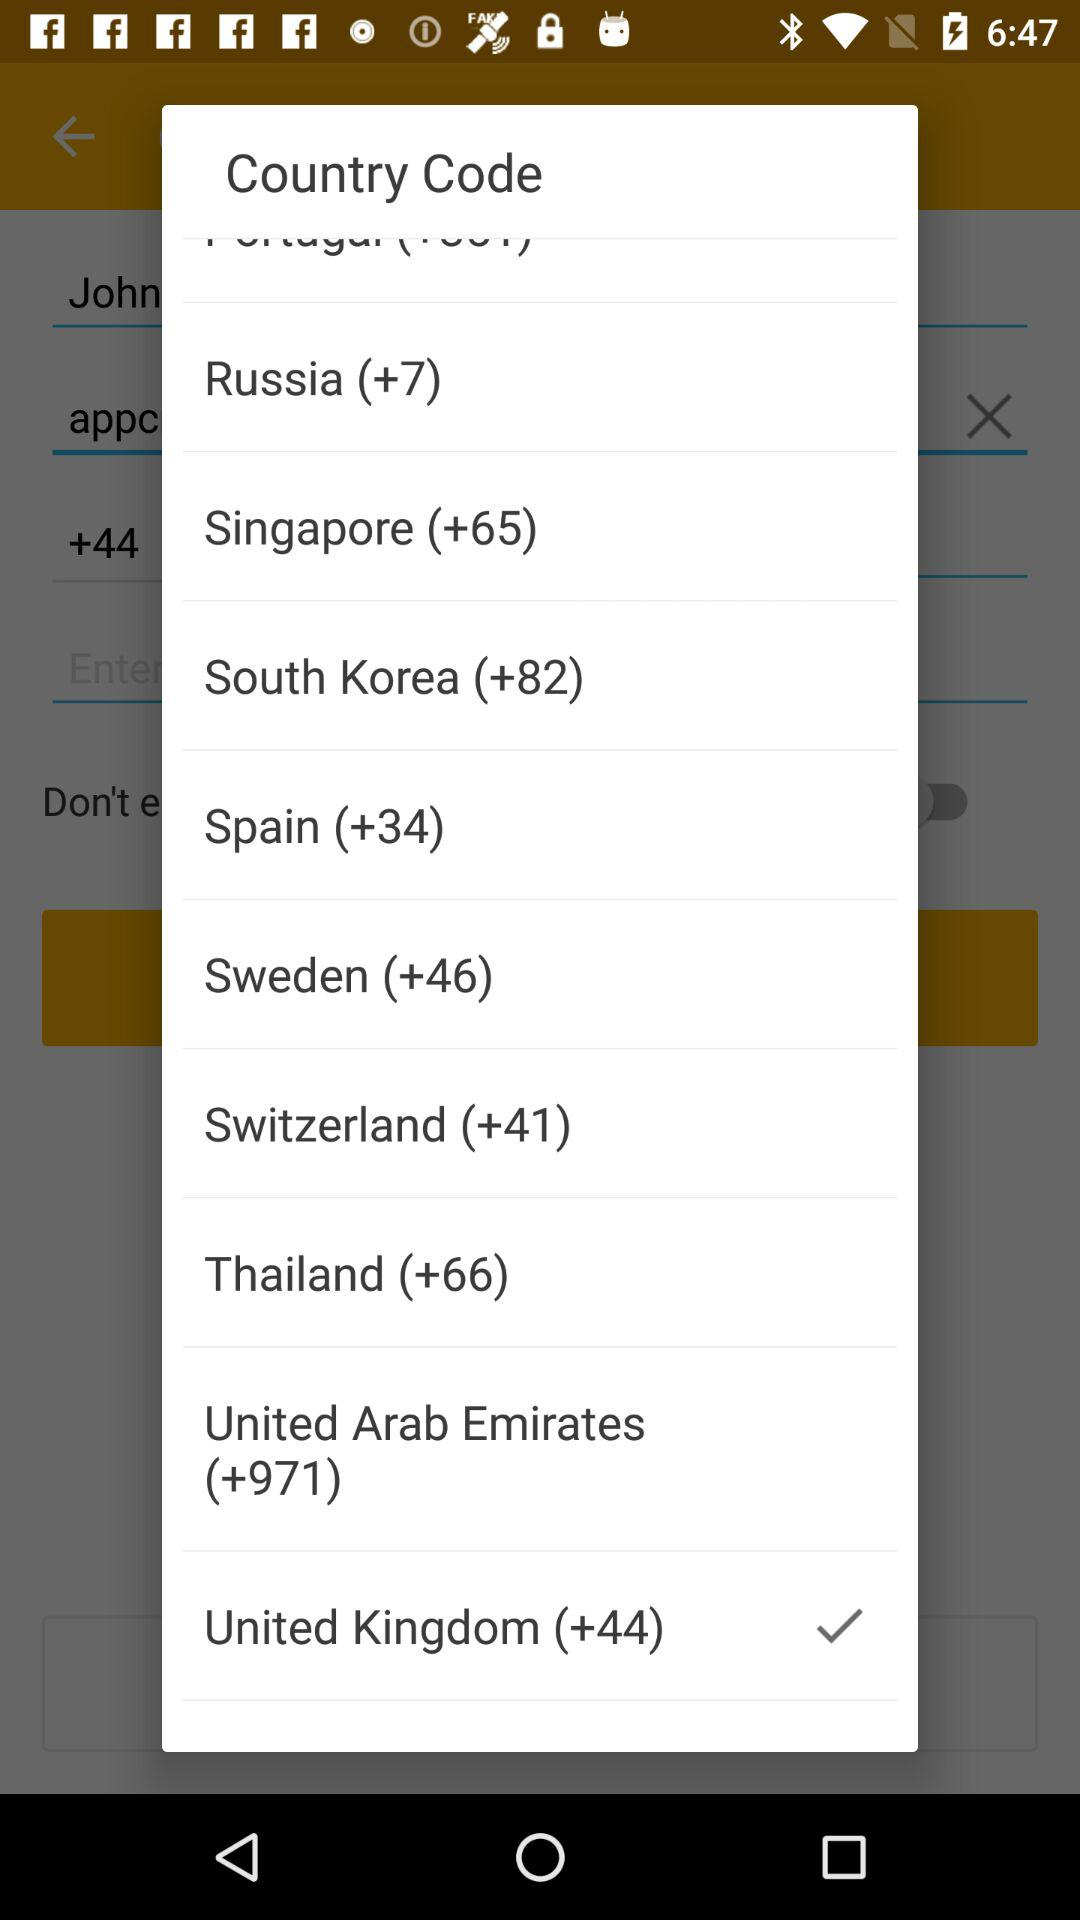What is the country code for Russia? The country code for Russia is +7. 